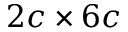<formula> <loc_0><loc_0><loc_500><loc_500>2 c \times 6 c</formula> 